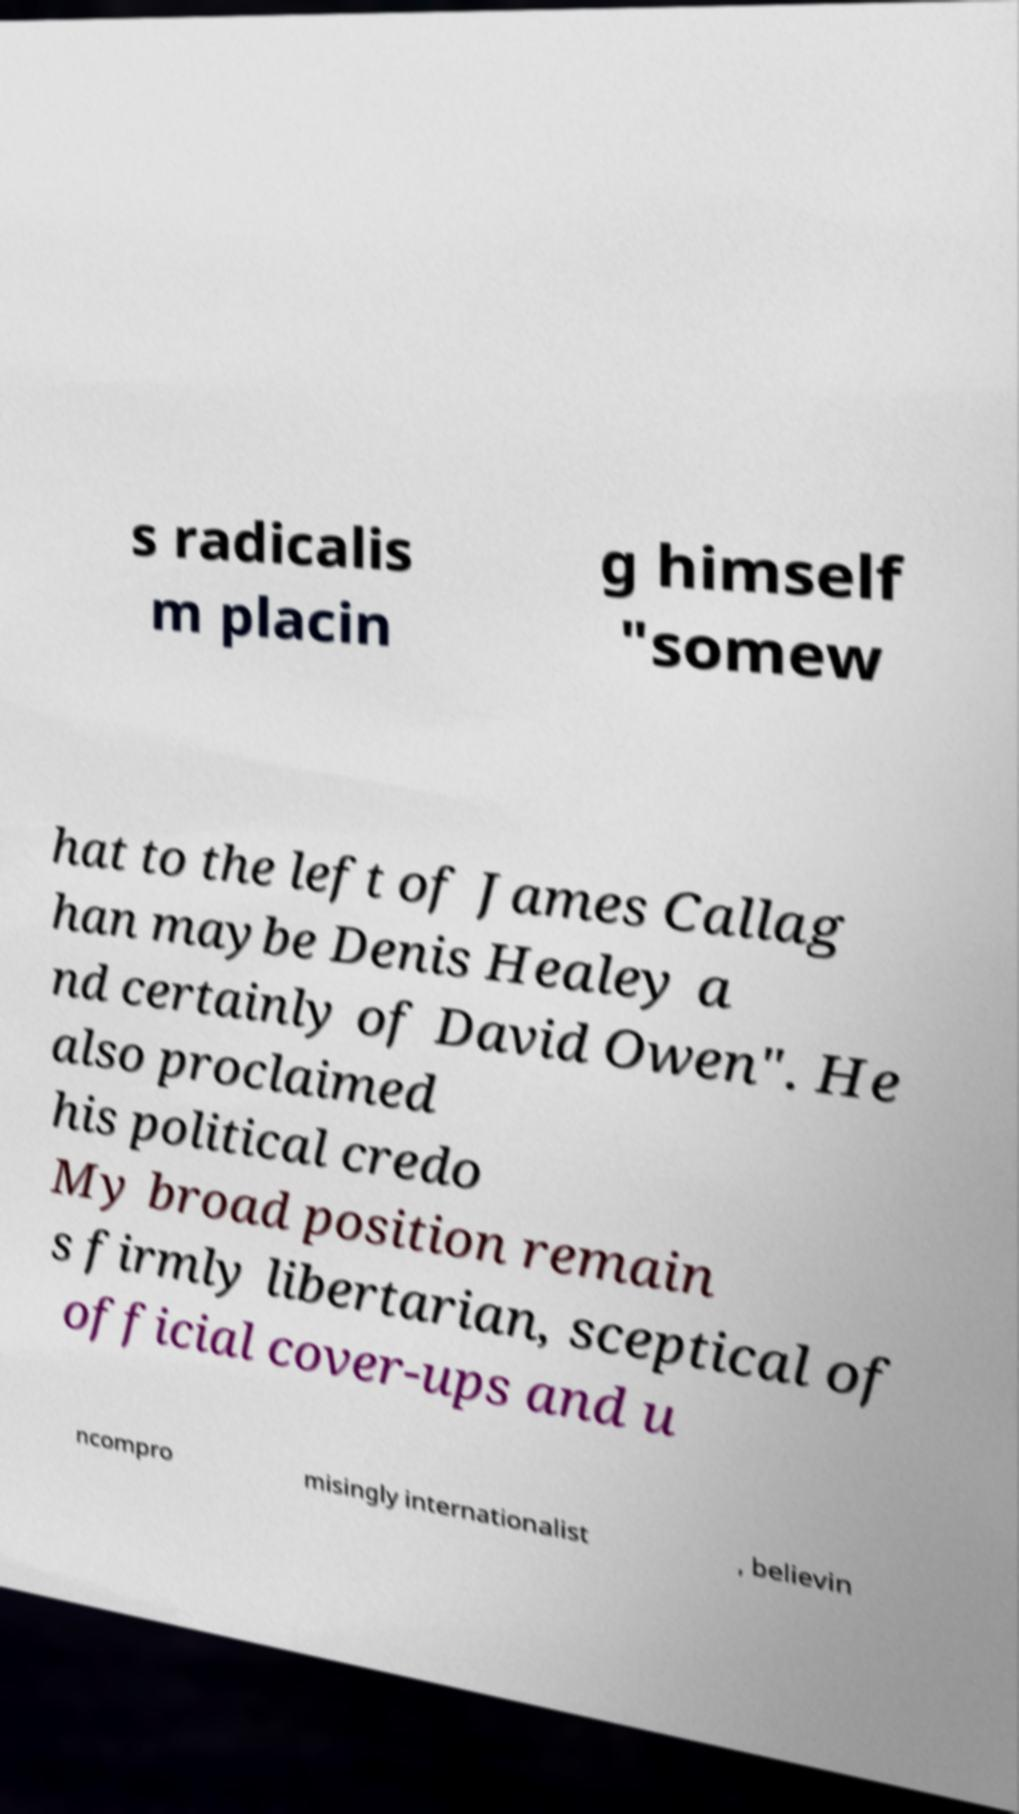For documentation purposes, I need the text within this image transcribed. Could you provide that? s radicalis m placin g himself "somew hat to the left of James Callag han maybe Denis Healey a nd certainly of David Owen". He also proclaimed his political credo My broad position remain s firmly libertarian, sceptical of official cover-ups and u ncompro misingly internationalist , believin 